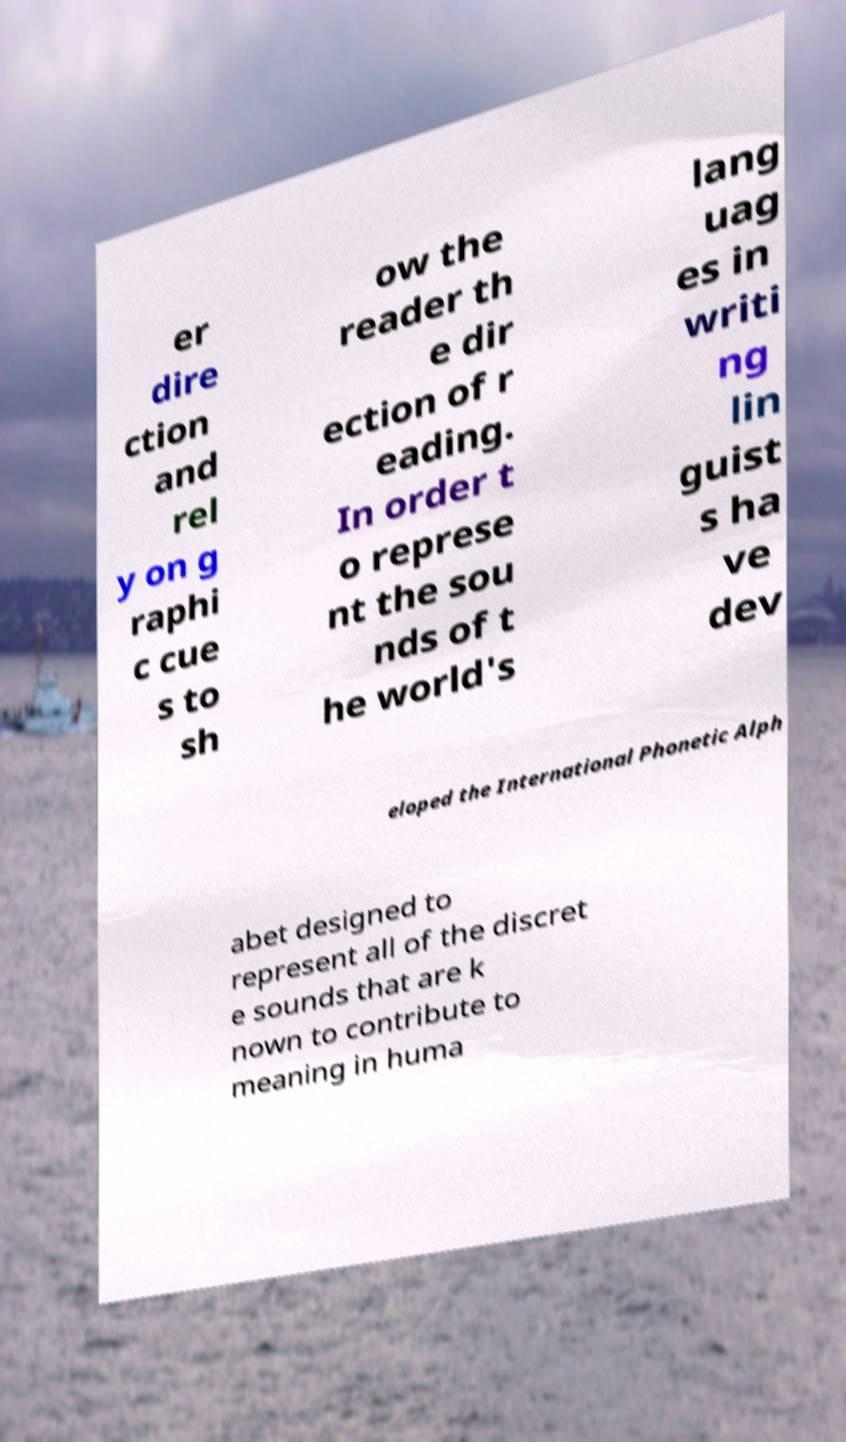Please read and relay the text visible in this image. What does it say? er dire ction and rel y on g raphi c cue s to sh ow the reader th e dir ection of r eading. In order t o represe nt the sou nds of t he world's lang uag es in writi ng lin guist s ha ve dev eloped the International Phonetic Alph abet designed to represent all of the discret e sounds that are k nown to contribute to meaning in huma 